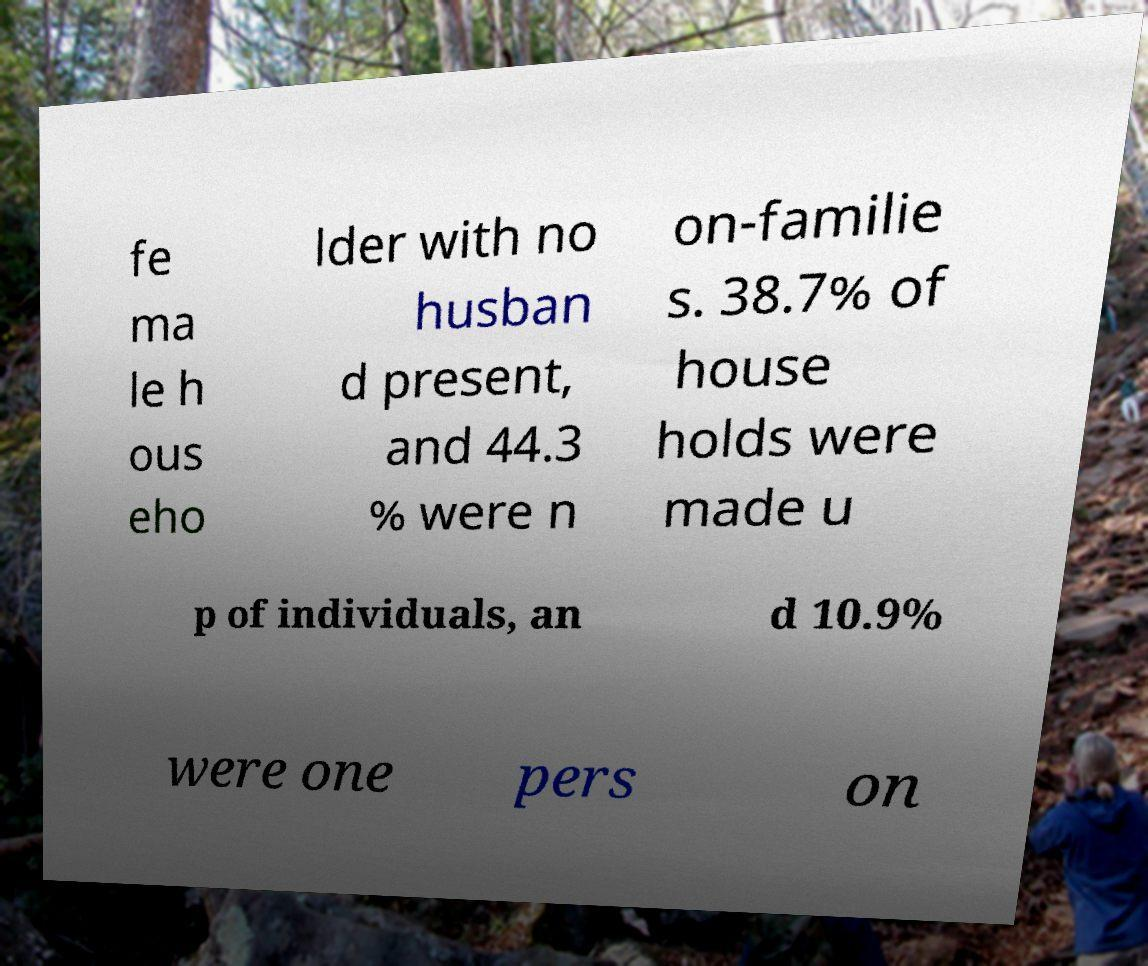I need the written content from this picture converted into text. Can you do that? fe ma le h ous eho lder with no husban d present, and 44.3 % were n on-familie s. 38.7% of house holds were made u p of individuals, an d 10.9% were one pers on 